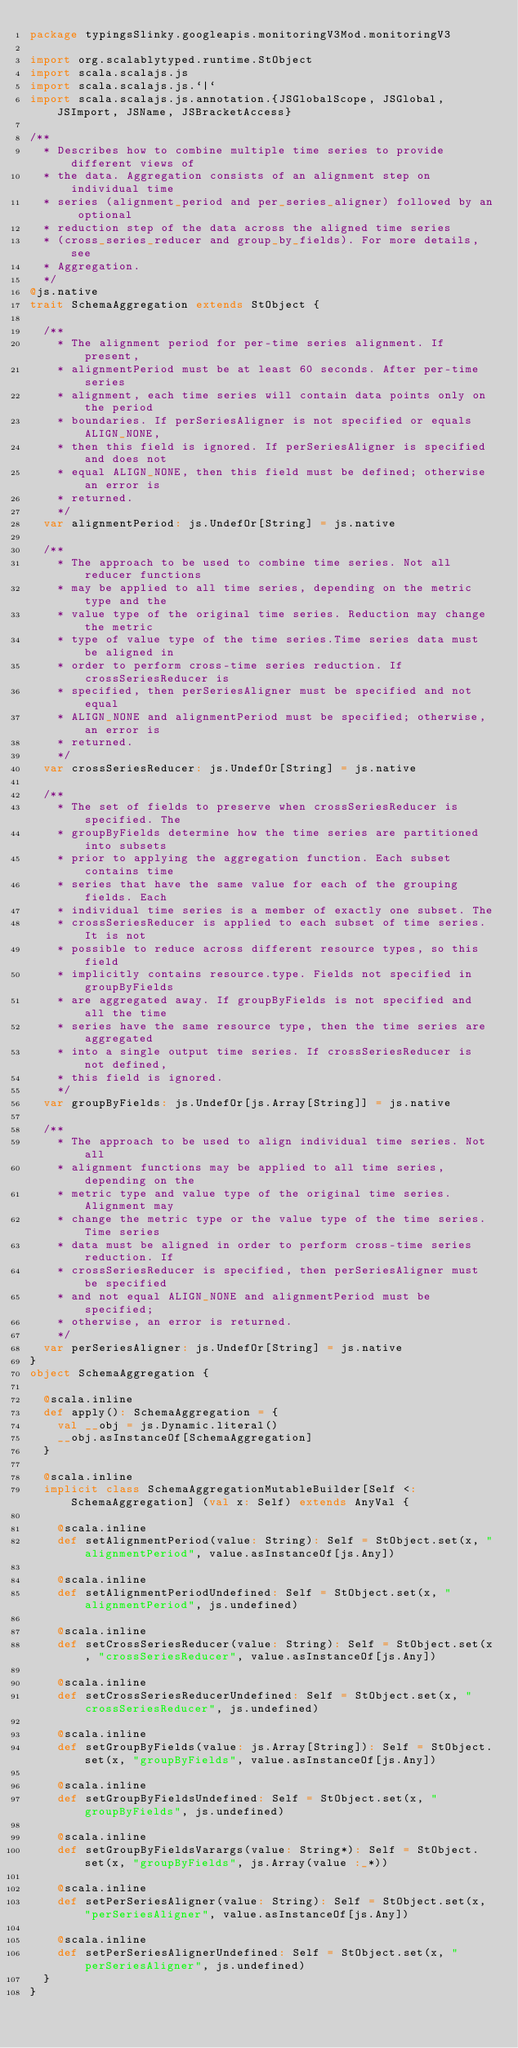Convert code to text. <code><loc_0><loc_0><loc_500><loc_500><_Scala_>package typingsSlinky.googleapis.monitoringV3Mod.monitoringV3

import org.scalablytyped.runtime.StObject
import scala.scalajs.js
import scala.scalajs.js.`|`
import scala.scalajs.js.annotation.{JSGlobalScope, JSGlobal, JSImport, JSName, JSBracketAccess}

/**
  * Describes how to combine multiple time series to provide different views of
  * the data. Aggregation consists of an alignment step on individual time
  * series (alignment_period and per_series_aligner) followed by an optional
  * reduction step of the data across the aligned time series
  * (cross_series_reducer and group_by_fields). For more details, see
  * Aggregation.
  */
@js.native
trait SchemaAggregation extends StObject {
  
  /**
    * The alignment period for per-time series alignment. If present,
    * alignmentPeriod must be at least 60 seconds. After per-time series
    * alignment, each time series will contain data points only on the period
    * boundaries. If perSeriesAligner is not specified or equals ALIGN_NONE,
    * then this field is ignored. If perSeriesAligner is specified and does not
    * equal ALIGN_NONE, then this field must be defined; otherwise an error is
    * returned.
    */
  var alignmentPeriod: js.UndefOr[String] = js.native
  
  /**
    * The approach to be used to combine time series. Not all reducer functions
    * may be applied to all time series, depending on the metric type and the
    * value type of the original time series. Reduction may change the metric
    * type of value type of the time series.Time series data must be aligned in
    * order to perform cross-time series reduction. If crossSeriesReducer is
    * specified, then perSeriesAligner must be specified and not equal
    * ALIGN_NONE and alignmentPeriod must be specified; otherwise, an error is
    * returned.
    */
  var crossSeriesReducer: js.UndefOr[String] = js.native
  
  /**
    * The set of fields to preserve when crossSeriesReducer is specified. The
    * groupByFields determine how the time series are partitioned into subsets
    * prior to applying the aggregation function. Each subset contains time
    * series that have the same value for each of the grouping fields. Each
    * individual time series is a member of exactly one subset. The
    * crossSeriesReducer is applied to each subset of time series. It is not
    * possible to reduce across different resource types, so this field
    * implicitly contains resource.type. Fields not specified in groupByFields
    * are aggregated away. If groupByFields is not specified and all the time
    * series have the same resource type, then the time series are aggregated
    * into a single output time series. If crossSeriesReducer is not defined,
    * this field is ignored.
    */
  var groupByFields: js.UndefOr[js.Array[String]] = js.native
  
  /**
    * The approach to be used to align individual time series. Not all
    * alignment functions may be applied to all time series, depending on the
    * metric type and value type of the original time series. Alignment may
    * change the metric type or the value type of the time series.Time series
    * data must be aligned in order to perform cross-time series reduction. If
    * crossSeriesReducer is specified, then perSeriesAligner must be specified
    * and not equal ALIGN_NONE and alignmentPeriod must be specified;
    * otherwise, an error is returned.
    */
  var perSeriesAligner: js.UndefOr[String] = js.native
}
object SchemaAggregation {
  
  @scala.inline
  def apply(): SchemaAggregation = {
    val __obj = js.Dynamic.literal()
    __obj.asInstanceOf[SchemaAggregation]
  }
  
  @scala.inline
  implicit class SchemaAggregationMutableBuilder[Self <: SchemaAggregation] (val x: Self) extends AnyVal {
    
    @scala.inline
    def setAlignmentPeriod(value: String): Self = StObject.set(x, "alignmentPeriod", value.asInstanceOf[js.Any])
    
    @scala.inline
    def setAlignmentPeriodUndefined: Self = StObject.set(x, "alignmentPeriod", js.undefined)
    
    @scala.inline
    def setCrossSeriesReducer(value: String): Self = StObject.set(x, "crossSeriesReducer", value.asInstanceOf[js.Any])
    
    @scala.inline
    def setCrossSeriesReducerUndefined: Self = StObject.set(x, "crossSeriesReducer", js.undefined)
    
    @scala.inline
    def setGroupByFields(value: js.Array[String]): Self = StObject.set(x, "groupByFields", value.asInstanceOf[js.Any])
    
    @scala.inline
    def setGroupByFieldsUndefined: Self = StObject.set(x, "groupByFields", js.undefined)
    
    @scala.inline
    def setGroupByFieldsVarargs(value: String*): Self = StObject.set(x, "groupByFields", js.Array(value :_*))
    
    @scala.inline
    def setPerSeriesAligner(value: String): Self = StObject.set(x, "perSeriesAligner", value.asInstanceOf[js.Any])
    
    @scala.inline
    def setPerSeriesAlignerUndefined: Self = StObject.set(x, "perSeriesAligner", js.undefined)
  }
}
</code> 